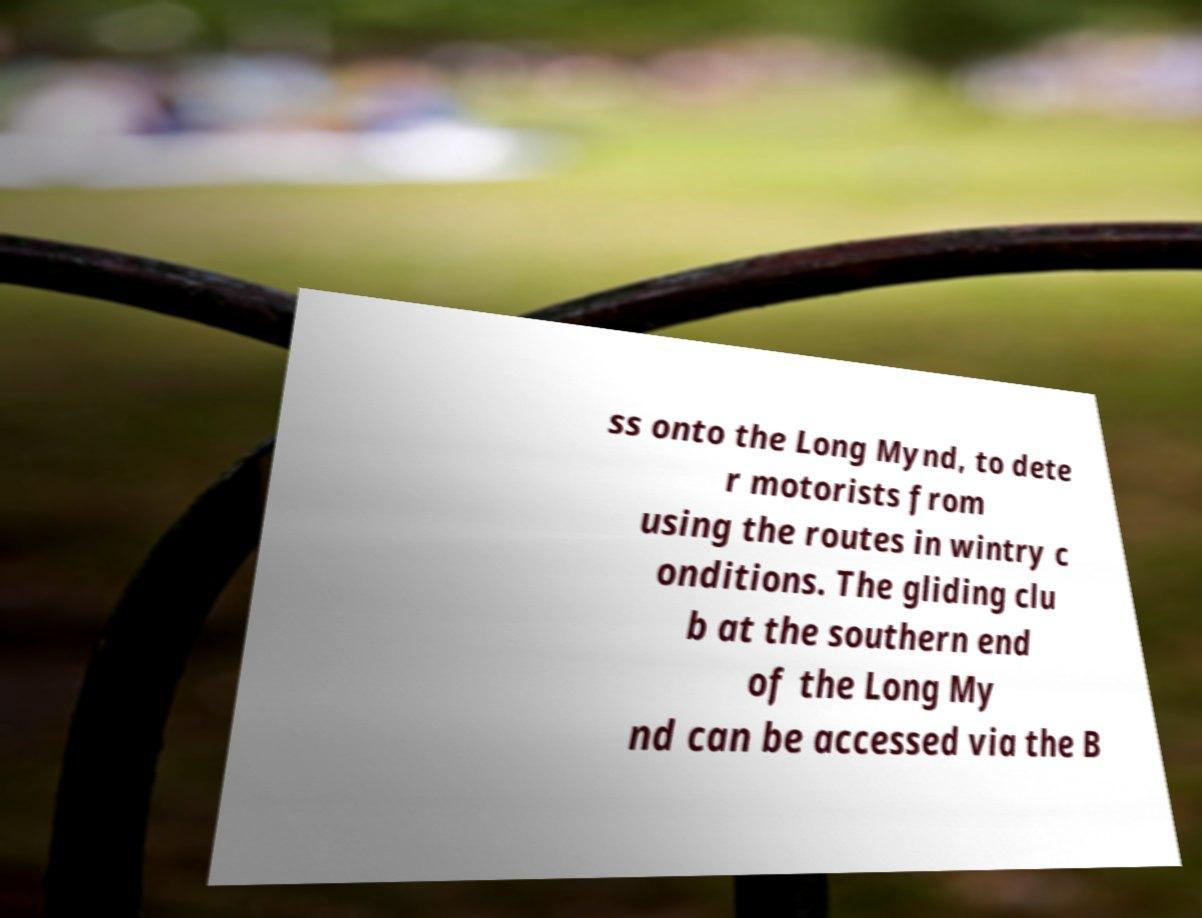Please read and relay the text visible in this image. What does it say? ss onto the Long Mynd, to dete r motorists from using the routes in wintry c onditions. The gliding clu b at the southern end of the Long My nd can be accessed via the B 